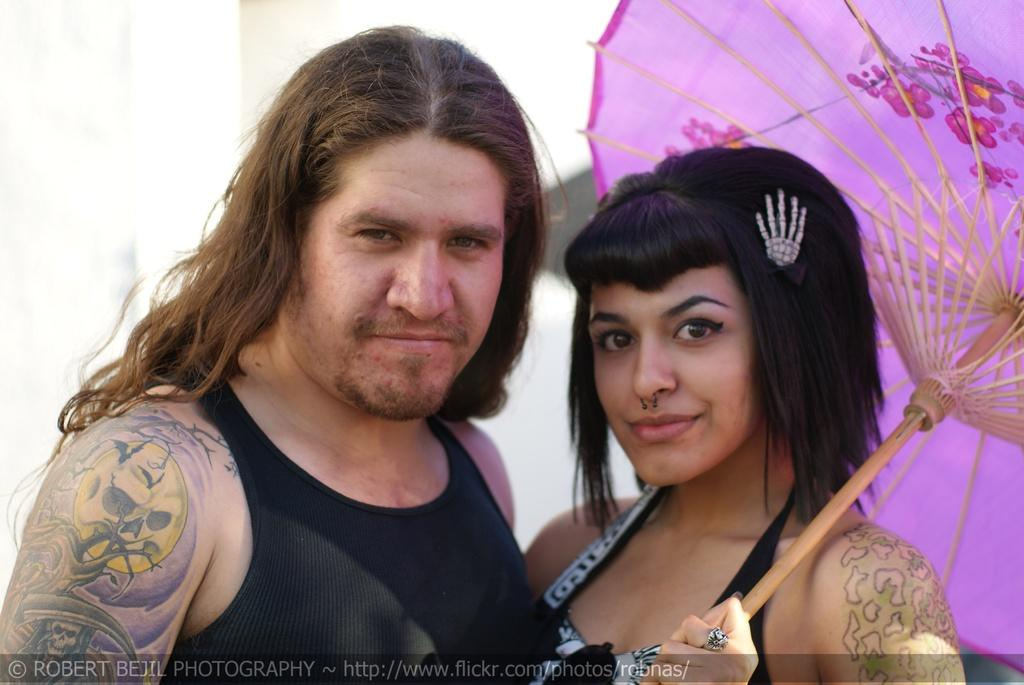How many people are present in the image? There are two people in the image. Can you describe one of the people in the image? One of the people is a woman. What is the woman holding in the image? The woman is holding an umbrella. What type of school is depicted in the image? There is no school present in the image; it features two people, one of whom is a woman holding an umbrella. What kind of nation is represented by the people in the image? The image does not depict a specific nation; it simply shows two people, one of whom is a woman holding an umbrella. 